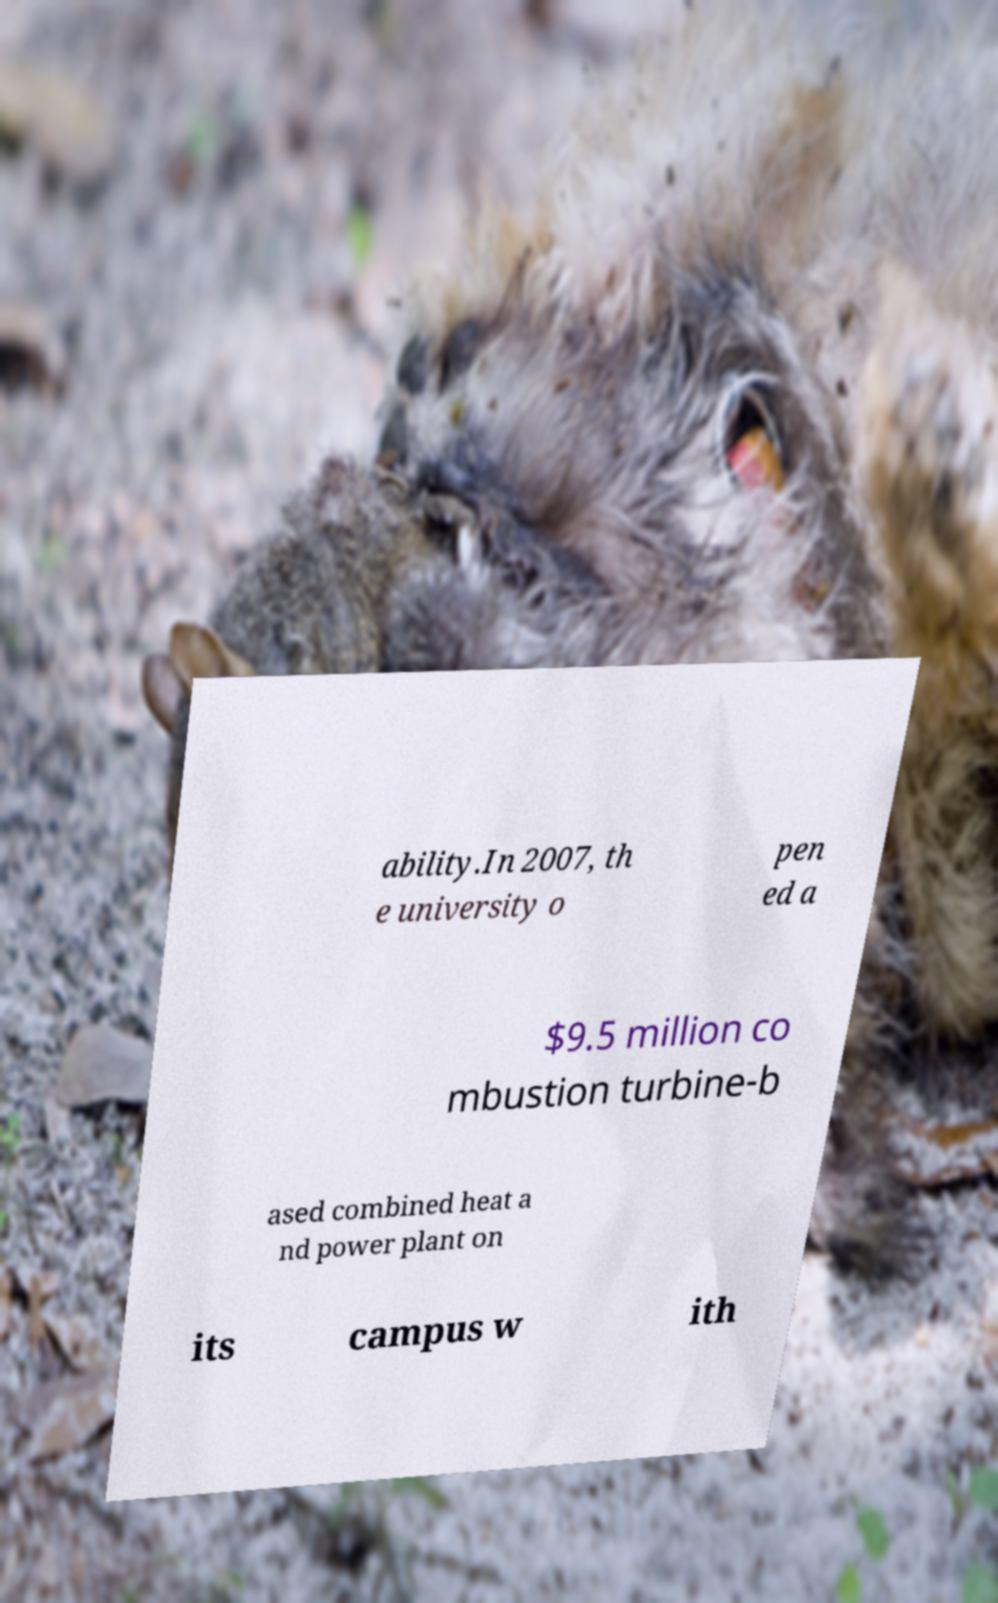Please identify and transcribe the text found in this image. ability.In 2007, th e university o pen ed a $9.5 million co mbustion turbine-b ased combined heat a nd power plant on its campus w ith 